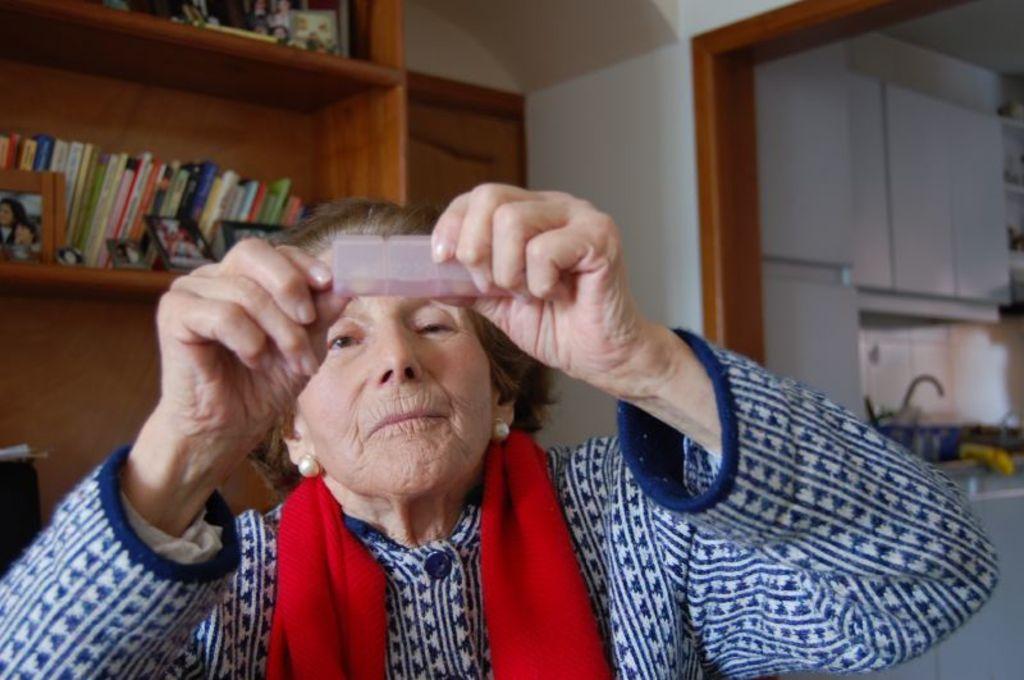Please provide a concise description of this image. In this image I can see a woman and I can see she is holding an object. I can also see she is wearing blue and white colour dress and on her shoulders I can see a red colour cloth. In the background I can see number of books and few frames on the shelves. On the right side of the image I can see few cupboards, a water tap and few other stuffs. I can also see this image is little bit blurry in the background. 